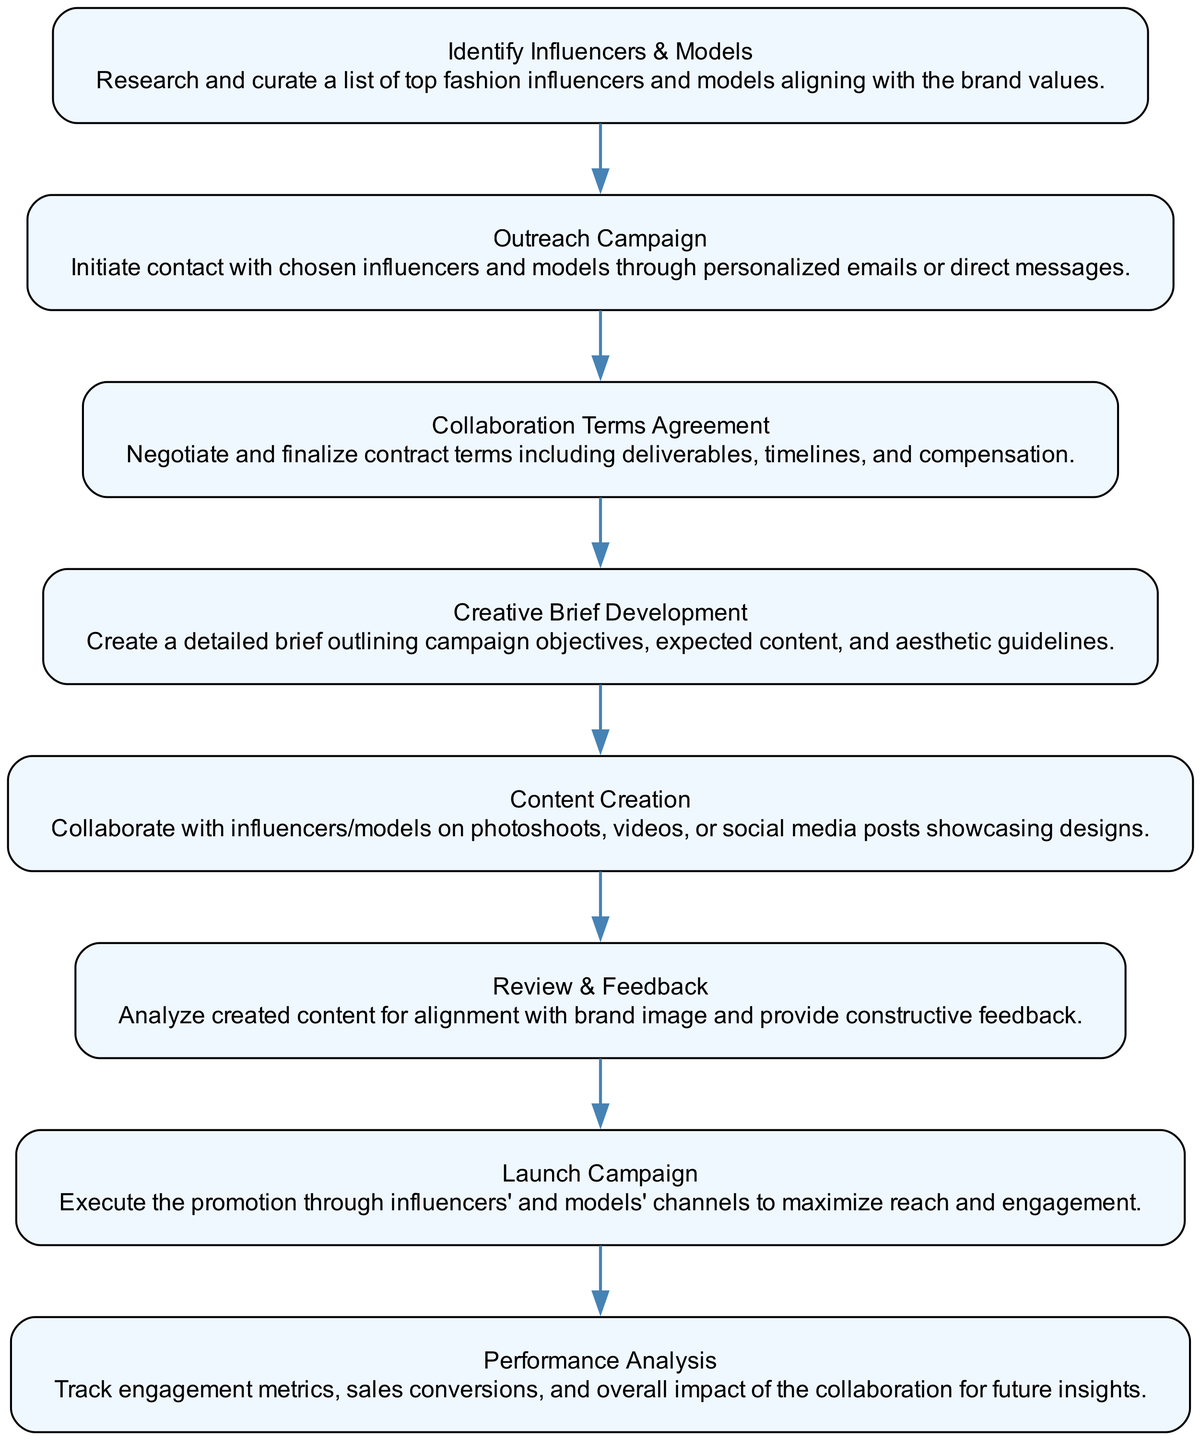What is the first step in the collaboration workflow? The first step, as indicated in the diagram, is "Identify Influencers & Models." This node clearly represents the initial action required in the flow.
Answer: Identify Influencers & Models How many nodes are in the diagram? By counting each distinct step in the diagram, we arrive at a total of eight nodes. Each step represents a unique phase in the workflow related to influencer and model collaboration.
Answer: Eight What action follows "Outreach Campaign"? The flow chart shows that the next action after "Outreach Campaign" is "Collaboration Terms Agreement," which is clearly linked in the sequence of the workflow.
Answer: Collaboration Terms Agreement Which node includes content analysis? The node that references content analysis is "Review & Feedback." This step specifically deals with reviewing the generated content against brand alignment, which includes analysis and feedback.
Answer: Review & Feedback What are the last two steps in the workflow? In tracing the final steps of the flow chart, we note that "Launch Campaign" is followed by "Performance Analysis." These are the concluding stages of the collaboration process.
Answer: Launch Campaign, Performance Analysis Which node directly precedes "Content Creation"? The node right before "Content Creation" is "Creative Brief Development." This indicates that the creative brief needs to be developed prior to content creation.
Answer: Creative Brief Development How many edges connect the nodes in the diagram? Each connection between nodes is represented as an edge, and since there are eight nodes, there are seven edges linking them sequentially, indicating a single flow from one step to the next.
Answer: Seven What is the purpose of "Performance Analysis"? The purpose of "Performance Analysis" is to track engagement metrics, sales conversions, and the overall impact of the collaboration, which is necessary for drawing insights for future campaigns.
Answer: Track engagement metrics, sales conversions, and overall impact 